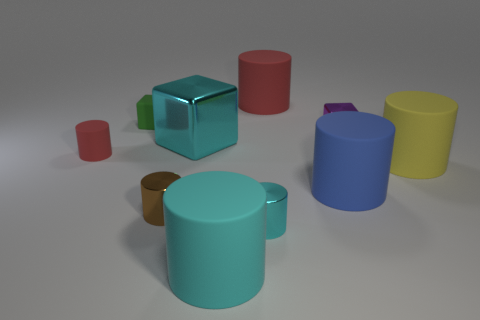What might be the purpose of these objects, assuming they are real? If these objects were real, they might serve various purposes. The cylindrical objects could be containers or cups due to their shapes, whereas the cubes could serve as storage boxes, dice, or decorative objects.  Is there any object that could be used to hold liquid? Yes, the yellow and teal cylindrical objects could potentially hold liquid due to their open tops and hollow shapes. 